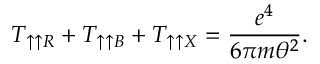<formula> <loc_0><loc_0><loc_500><loc_500>T _ { \uparrow \uparrow R } + T _ { \uparrow \uparrow B } + T _ { \uparrow \uparrow X } = \frac { e ^ { 4 } } { 6 \pi m \theta ^ { 2 } } .</formula> 